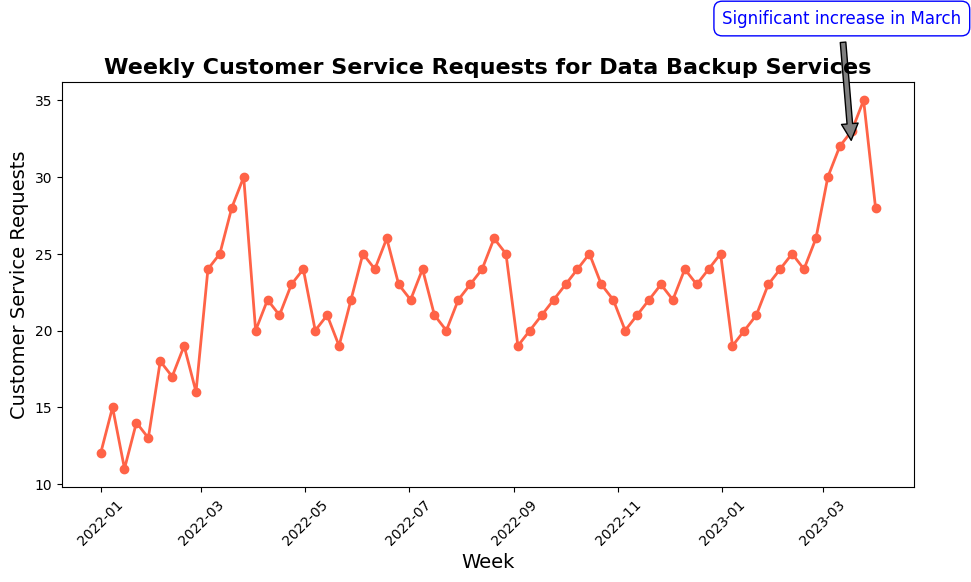What is the highest number of weekly customer service requests observed? The highest number of weekly customer service requests can be identified by looking for the peak of the line in the chart. The highest point on the graph is around the end of March 2023.
Answer: 35 During which period did the requests increase significantly, as noted by the annotation? There is an annotation on the chart pointing to a significant increase in March 2023, indicating that this is the period of interest.
Answer: March How many weeks in total showed 25 or more customer service requests? To find this, count all points along the line that are at or exceed 25 requests. Here, the weeks that meet this criterion are March 12th, March 19th, March 26th, June 4th, June 18th, October 15th, December 10th, December 24th, December 31st, February 11th, February 25th, March 4th, March 11th, March 18th, and March 25th.
Answer: 15 Which month experienced the lowest average weekly customer service requests, and what was this value? Identify the lowest points for each month and calculate the average for those months. The month with the lowest average is January 2022, with the values: 12, 15, 11, 14, and 13, averaging to (12+15+11+14+13)/5 = 13.
Answer: January 2022, 13 How many customer service requests were there in the first and last week, respectively, and what's their difference? The first week has 12 requests, and the last week has 28 requests. The difference is 28 - 12.
Answer: 16 What week in January 2023 had the highest number of requests? Check each week's data for January 2023 and identify the highest one. January 28th had 23 requests, which is the highest.
Answer: January 28 What is the trend of customer service requests in the last quarter of 2022? Observe the line from October 2022 to December 2022; it shows how the requests slightly increased over time.
Answer: Slight increase How often did the customer service requests in December exceed 22? There are five weeks in December 2022. The requests were 22, 24, 23, 24, and 25, so December 3rd, December 17th, December 24th, and December 31st exceed 22.
Answer: 4 weeks Compare the average number of service requests in March 2022 and March 2023. What is the difference between them? March 2022 has values: 24, 25, 28, 30. March 2023 has values: 30, 32, 33, 35. Calculate their averages [(24+25+28+30)/4 = 26.75], [(30+32+33+35)/4 = 32.5]. The difference is 32.5 - 26.75.
Answer: 5.75 During which weeks in March 2023 did the customer service requests consistently grow? Verify each week of March 2023: March 4th (30), March 11th (32), March 18th (33), and March 25th (35). Each week shows an increase from the previous one.
Answer: March 4th - March 25th 